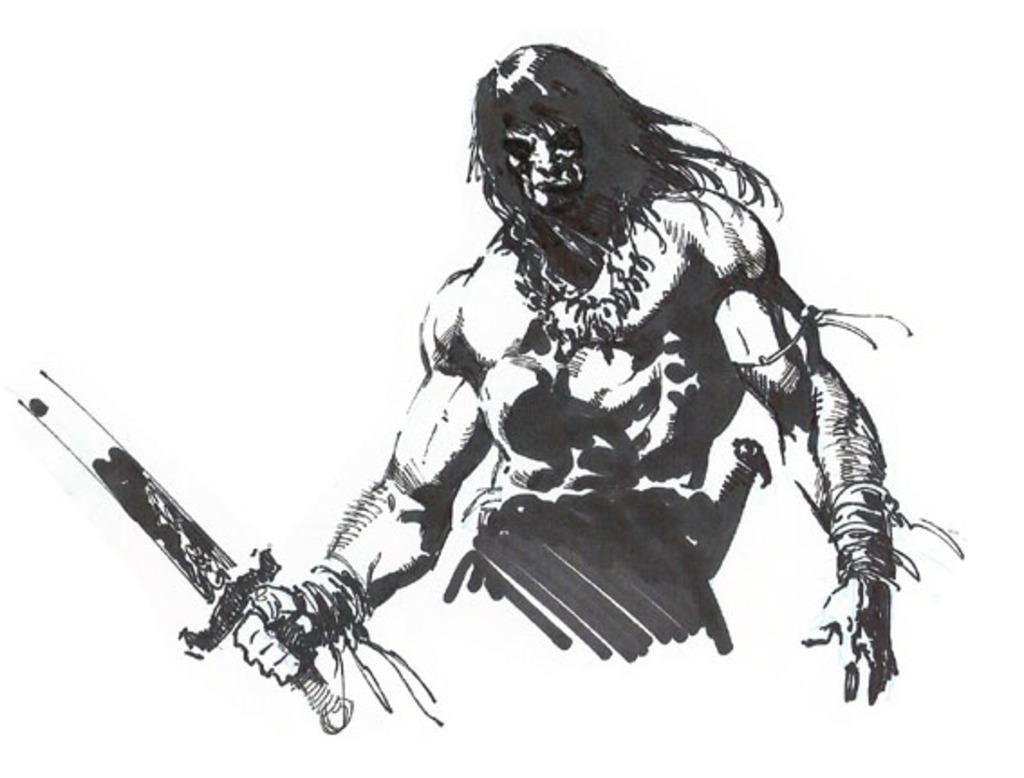Could you give a brief overview of what you see in this image? In this image we can see a animated picture. 